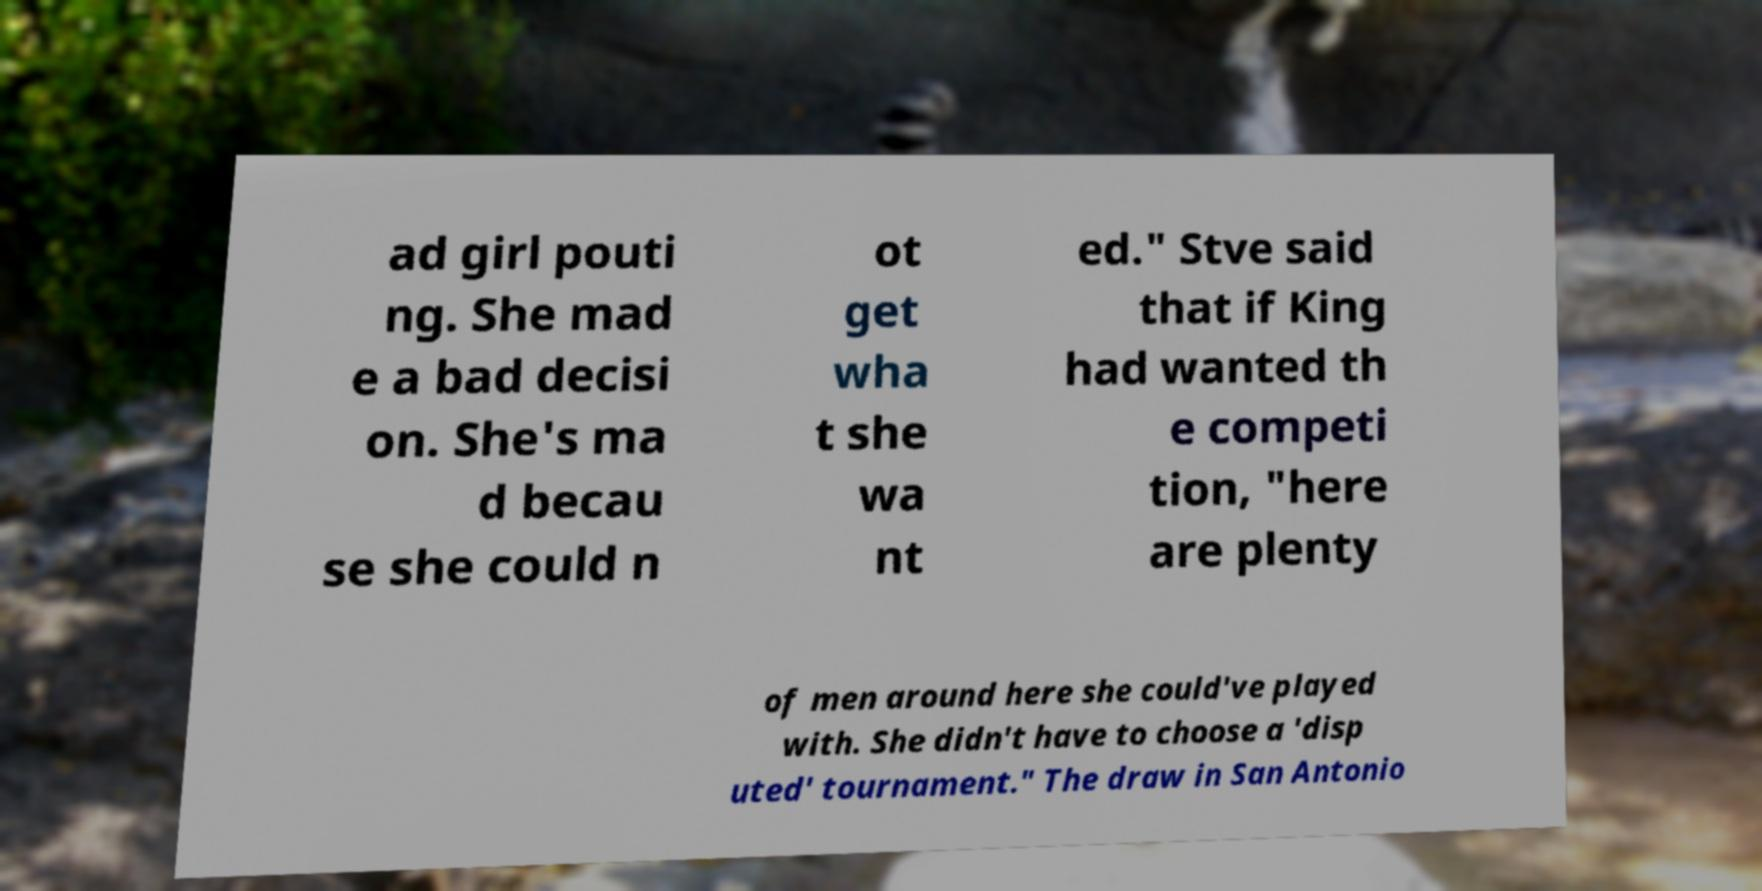Could you extract and type out the text from this image? ad girl pouti ng. She mad e a bad decisi on. She's ma d becau se she could n ot get wha t she wa nt ed." Stve said that if King had wanted th e competi tion, "here are plenty of men around here she could've played with. She didn't have to choose a 'disp uted' tournament." The draw in San Antonio 